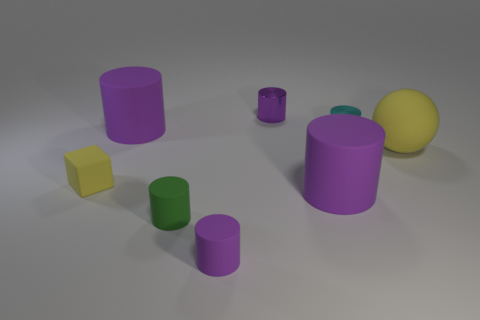How many purple cylinders must be subtracted to get 1 purple cylinders? 3 Subtract all cyan blocks. How many purple cylinders are left? 4 Subtract 1 cylinders. How many cylinders are left? 5 Subtract all cyan cylinders. How many cylinders are left? 5 Subtract all tiny green rubber cylinders. How many cylinders are left? 5 Subtract all cyan cylinders. Subtract all green blocks. How many cylinders are left? 5 Add 1 tiny yellow cylinders. How many objects exist? 9 Subtract all cylinders. How many objects are left? 2 Add 5 large blue matte spheres. How many large blue matte spheres exist? 5 Subtract 1 cyan cylinders. How many objects are left? 7 